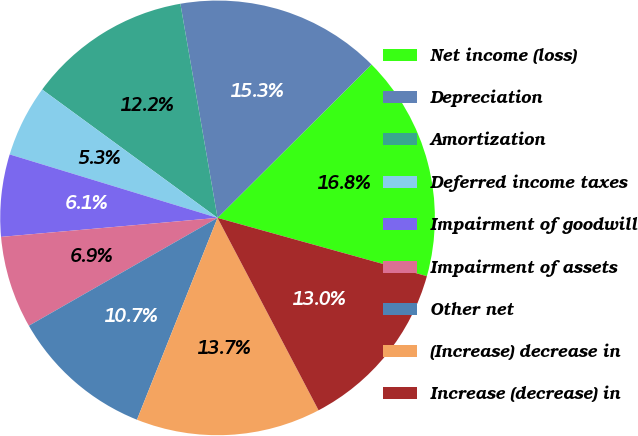Convert chart to OTSL. <chart><loc_0><loc_0><loc_500><loc_500><pie_chart><fcel>Net income (loss)<fcel>Depreciation<fcel>Amortization<fcel>Deferred income taxes<fcel>Impairment of goodwill<fcel>Impairment of assets<fcel>Other net<fcel>(Increase) decrease in<fcel>Increase (decrease) in<nl><fcel>16.79%<fcel>15.27%<fcel>12.21%<fcel>5.34%<fcel>6.11%<fcel>6.87%<fcel>10.69%<fcel>13.74%<fcel>12.98%<nl></chart> 